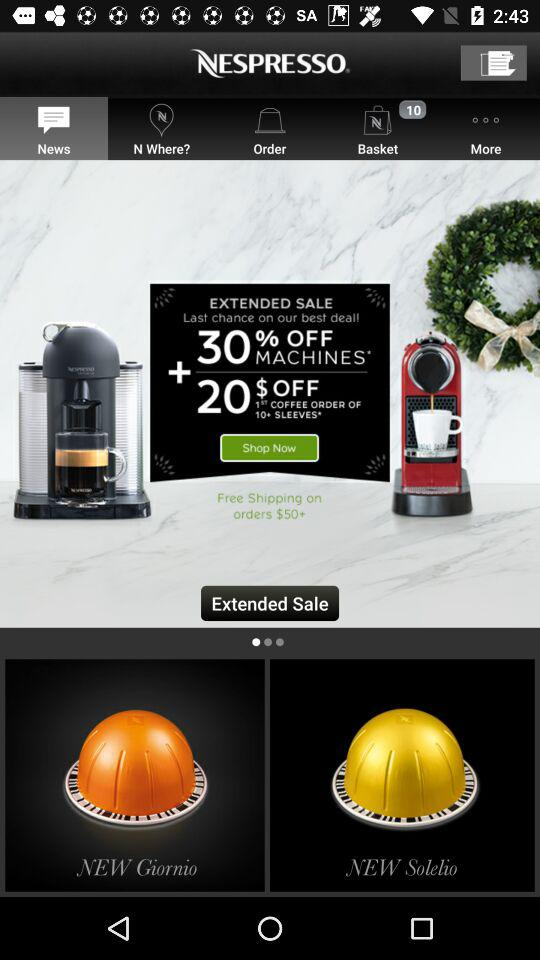What is the percentage off on "MACHINES"? The percentage off on "MACHINES" is 30. 